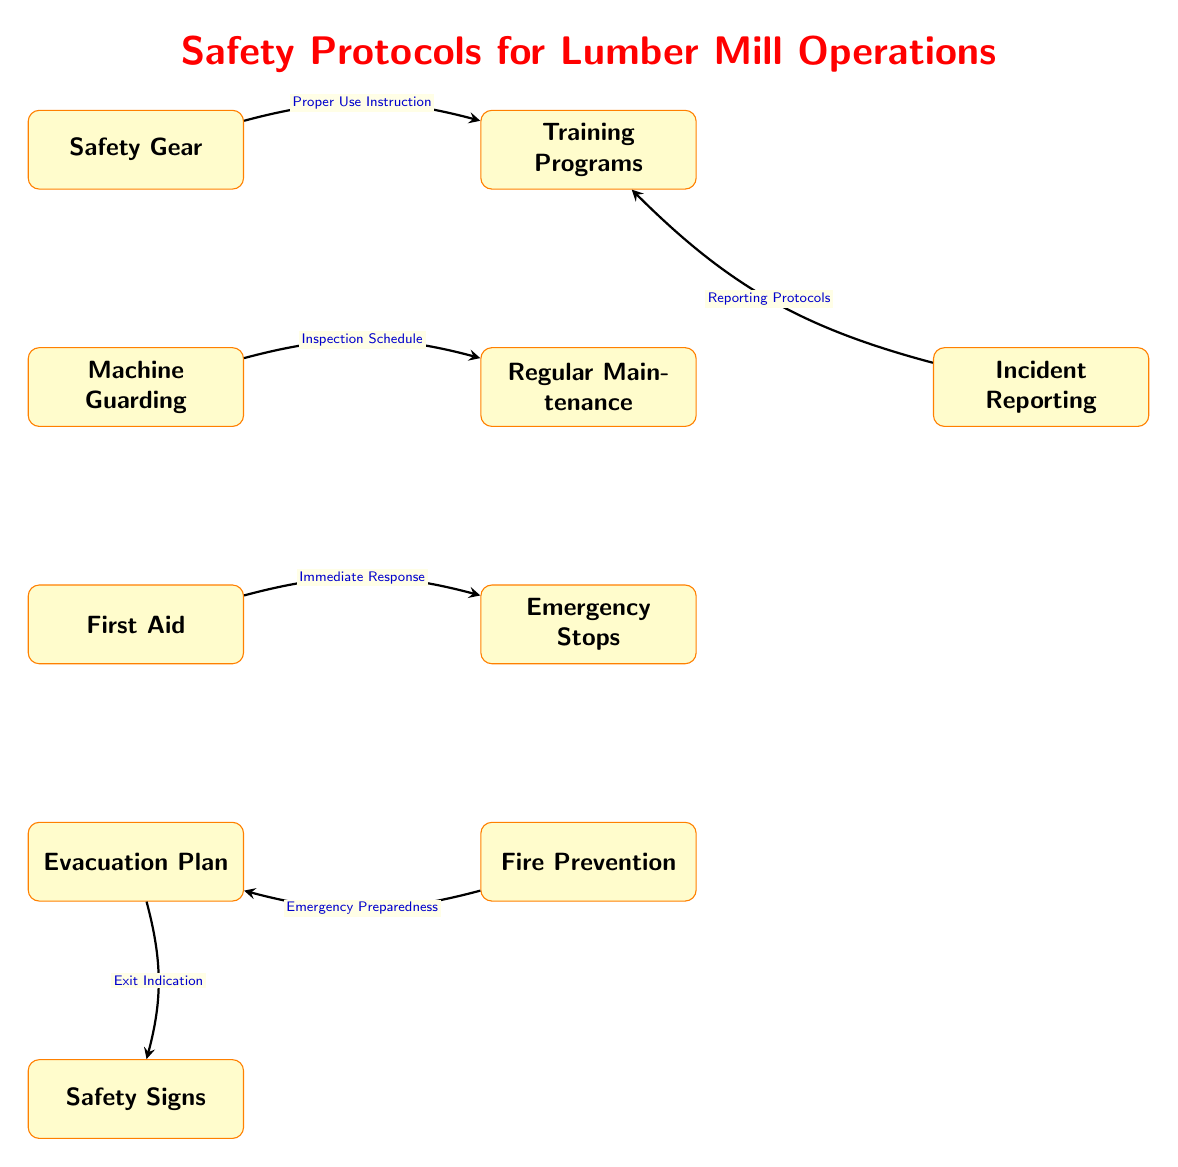What is the primary focus of the diagram? The title of the diagram clearly states "Safety Protocols for Lumber Mill Operations," which indicates that the diagram's main focus is on safety measures in lumber mill activities.
Answer: Safety Protocols for Lumber Mill Operations How many nodes are there in total? By counting each distinct safety measure or protocol represented in the diagram, there are ten nodes included in the structure.
Answer: 10 What safety measure comes before Training Programs? The diagram shows that Safety Gear is the predecessor to Training Programs, linked by the edge labeled "Proper Use Instruction."
Answer: Safety Gear Which node emphasizes immediate emergency response? The First Aid node specifically addresses immediate response to accidents or injuries, as indicated by its label.
Answer: First Aid What is the link between Emergency Stops and First Aid? The edge drawn between these two nodes is labeled "Immediate Response," suggesting a direct relationship focused on responding to emergencies.
Answer: Immediate Response How does Fire Prevention connect to Evacuation Plan? There is a direct edge drawn from Fire Prevention to Evacuation Plan that is labeled "Emergency Preparedness," indicating the flow of information and protocols relating to emergency actions.
Answer: Emergency Preparedness Which two nodes are placed in the lower section of the diagram? Upon examining the diagram layout, the nodes First Aid and Evacuation Plan are placed in the lower section, indicating their importance in emergency scenarios.
Answer: First Aid and Evacuation Plan What is indicated by the flow from Incident Reporting to Training Programs? The edge labeled "Reporting Protocols" connecting these nodes suggests that incident reporting contributes to the effectiveness of training programs in safety protocols.
Answer: Reporting Protocols What type of signage is associated with Evacuation Plan? The Evacuation Plan node is directly connected to the Safety Signs node by an edge labeled "Exit Indication," indicating it relates to the type of signage used.
Answer: Exit Indication 